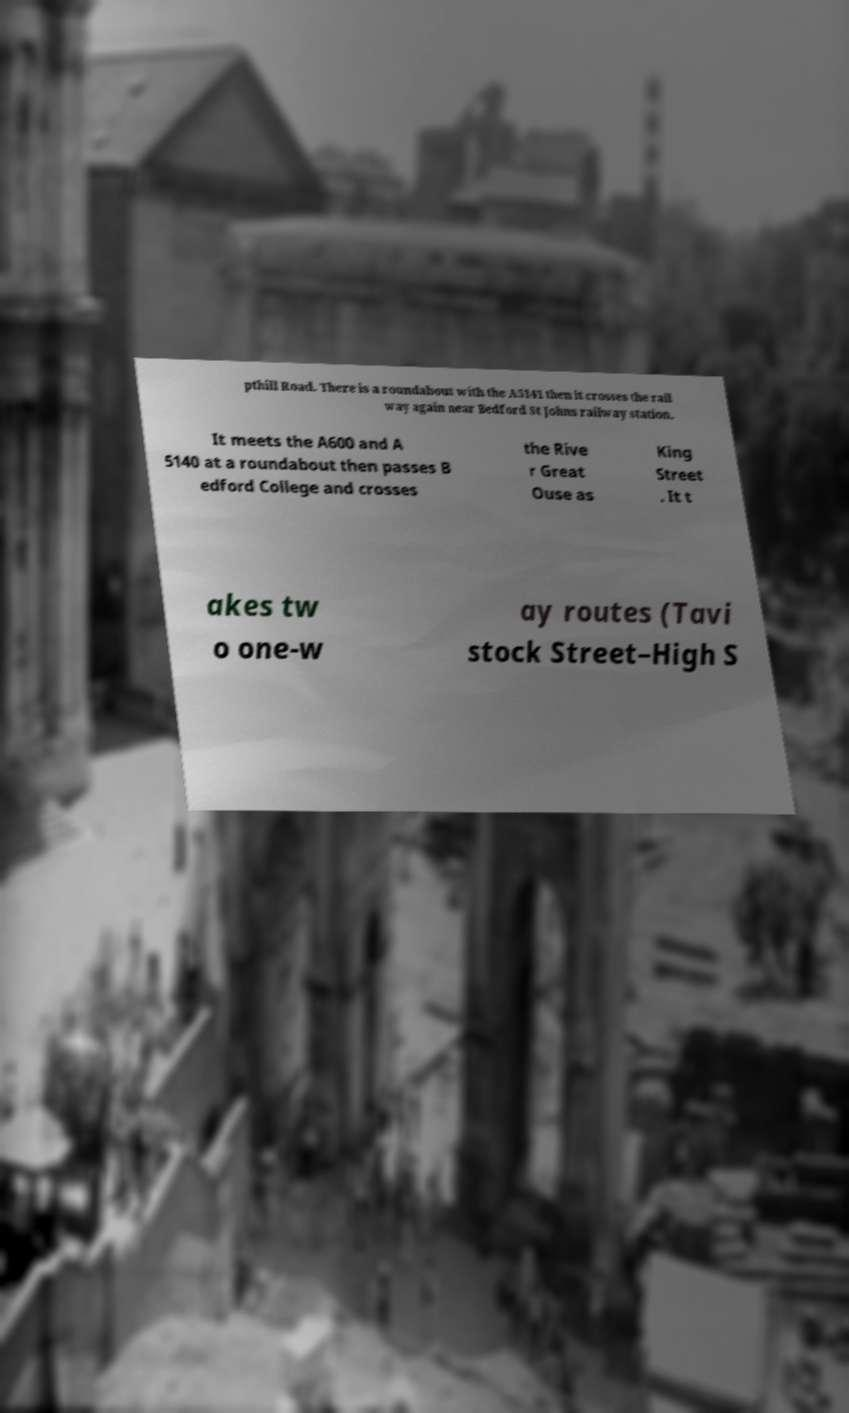Can you read and provide the text displayed in the image?This photo seems to have some interesting text. Can you extract and type it out for me? pthill Road. There is a roundabout with the A5141 then it crosses the rail way again near Bedford St Johns railway station. It meets the A600 and A 5140 at a roundabout then passes B edford College and crosses the Rive r Great Ouse as King Street . It t akes tw o one-w ay routes (Tavi stock Street–High S 